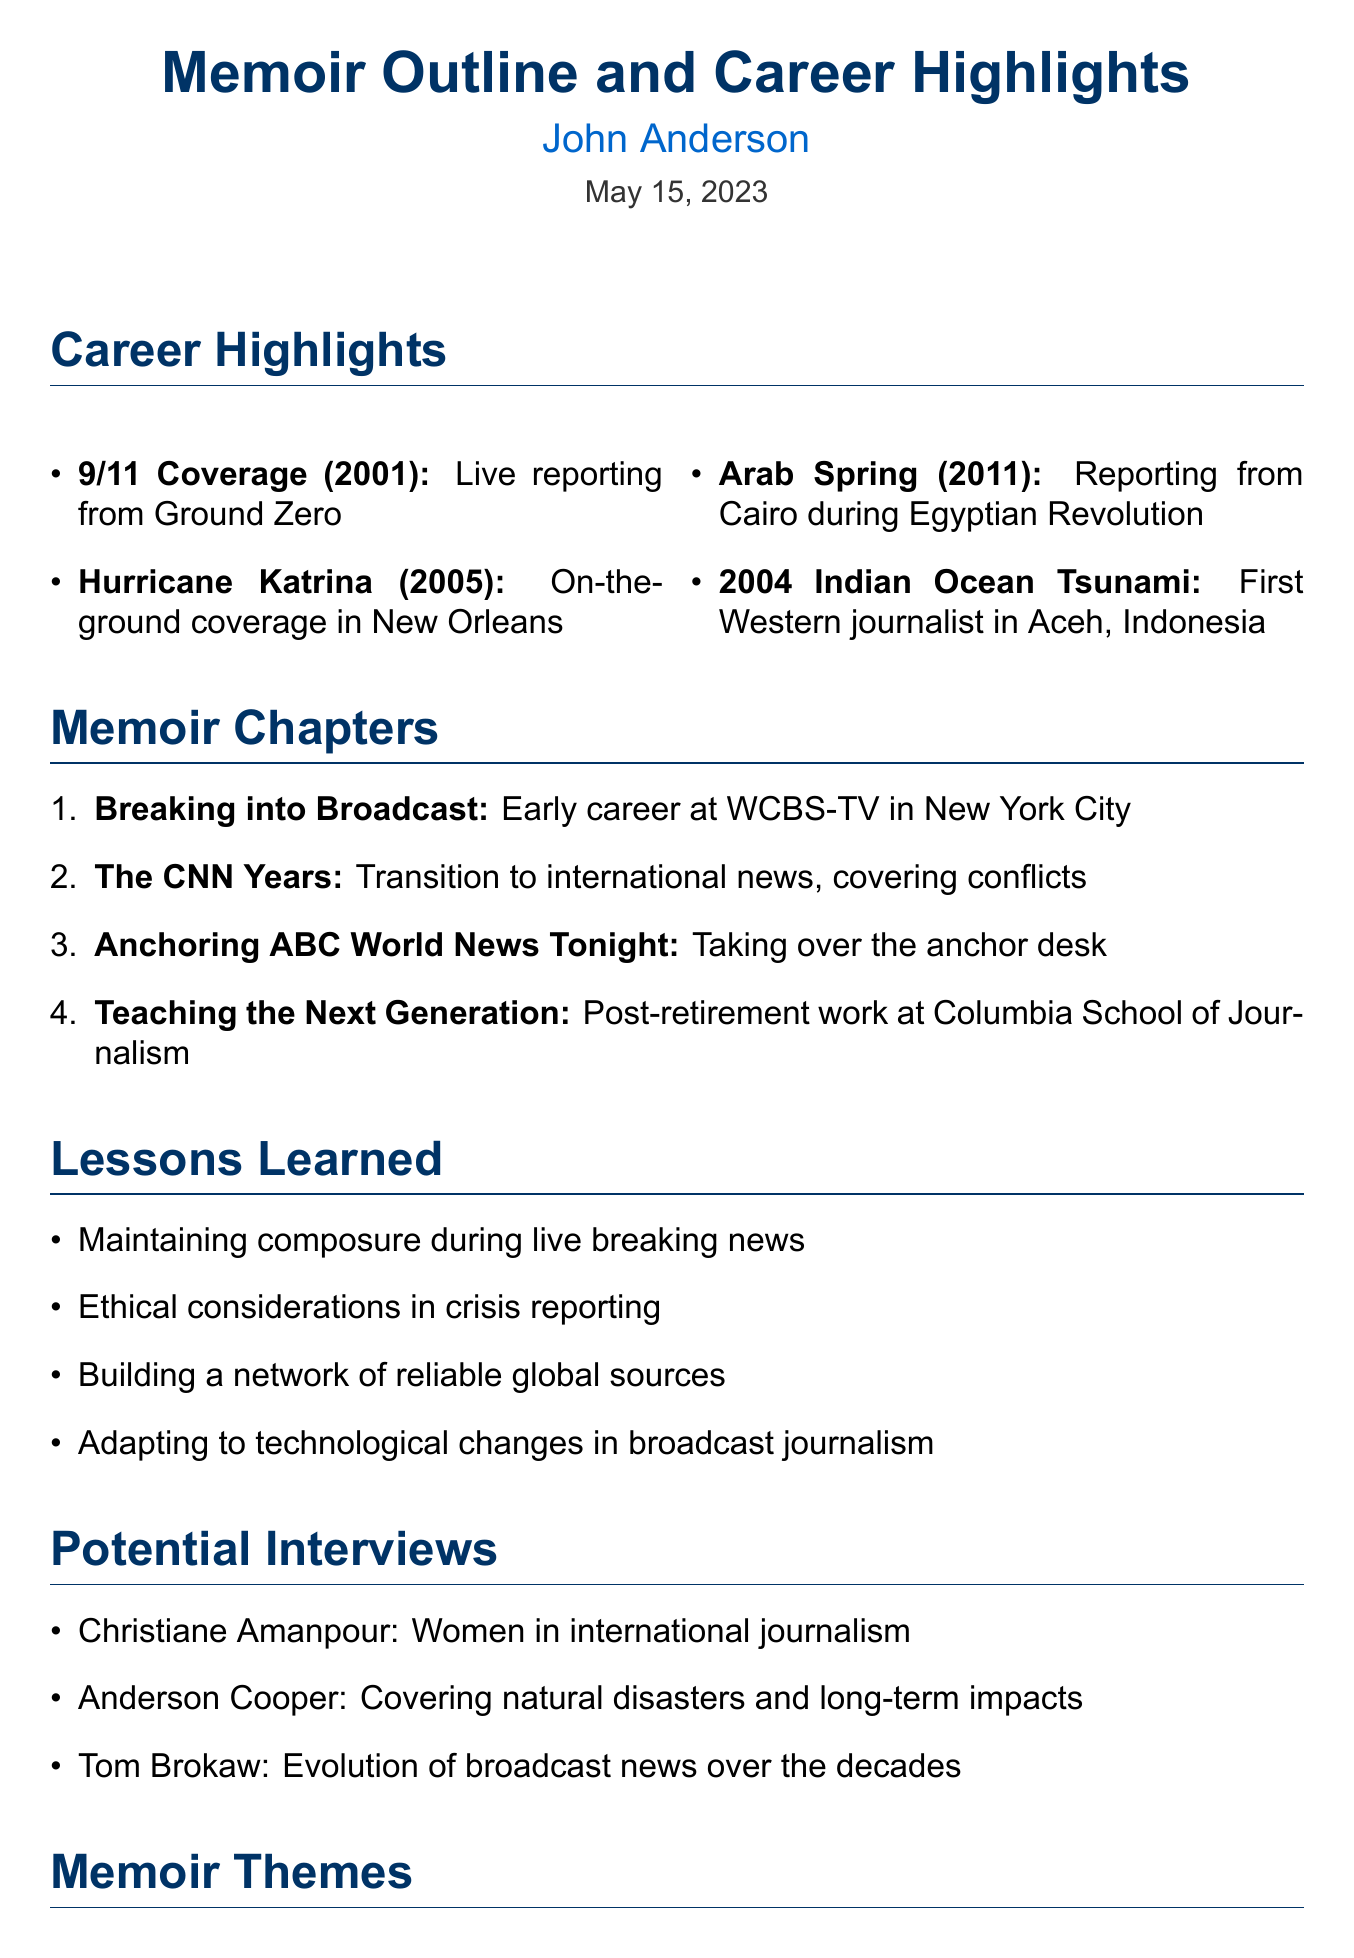What is the title of the memo? The title of the memo is indicated at the top of the document as the main subject.
Answer: Memoir Outline and Career Highlights Who is the author of the memoir? The author is mentioned in a prominent position within the document header.
Answer: John Anderson What year did the 9/11 coverage occur? The year is specified next to the event in the list of career highlights.
Answer: 2001 Which chapter discusses early career experiences? The specific chapter is listed in the memoir chapters section, indicating its focus on the initial phase of the author's career.
Answer: Breaking into Broadcast How many potential interviews are listed? The number is determined by counting the items in the potential interviews section of the document.
Answer: 3 What is one major theme of the memoir? This theme reflects the central concepts explored in the memoir themes section.
Answer: The adrenaline of breaking news In which year did the Arab Spring coverage take place? The year is explicitly stated alongside the event in the career highlights section.
Answer: 2011 What publishing option involves The New Yorker? This option is clearly outlined under the publishing considerations section, indicating a strategic choice for distribution.
Answer: Serializing parts of the memoir What lesson emphasizes composure during crises? This lesson is stated in the lessons learned section, referring to a crucial skill in crisis reporting.
Answer: Maintaining composure during live breaking news 